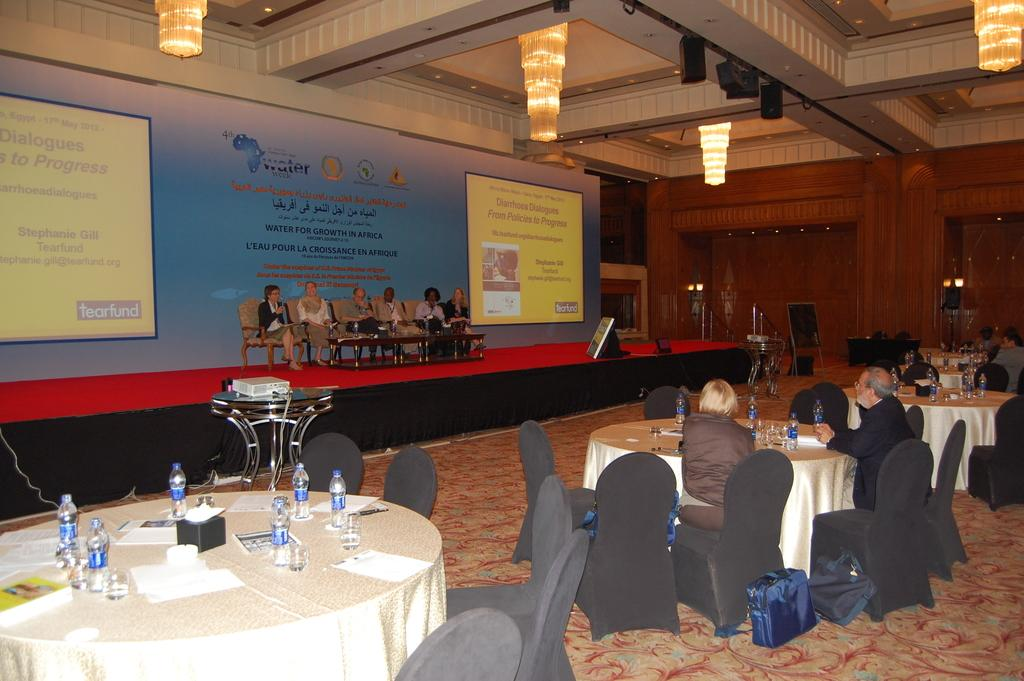What are the people in the image doing? The people in the image are sitting on chairs. What can be seen on the table in the image? There are water bottles on the table in the image. What type of glue is being used by the people in the image? There is no glue present in the image; the people are simply sitting on chairs. 